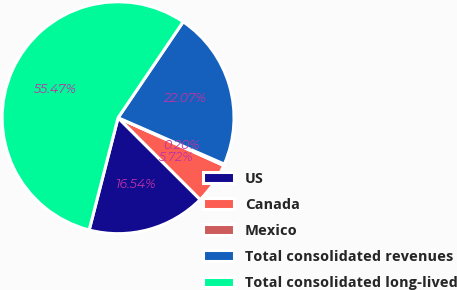Convert chart to OTSL. <chart><loc_0><loc_0><loc_500><loc_500><pie_chart><fcel>US<fcel>Canada<fcel>Mexico<fcel>Total consolidated revenues<fcel>Total consolidated long-lived<nl><fcel>16.54%<fcel>5.72%<fcel>0.2%<fcel>22.07%<fcel>55.48%<nl></chart> 